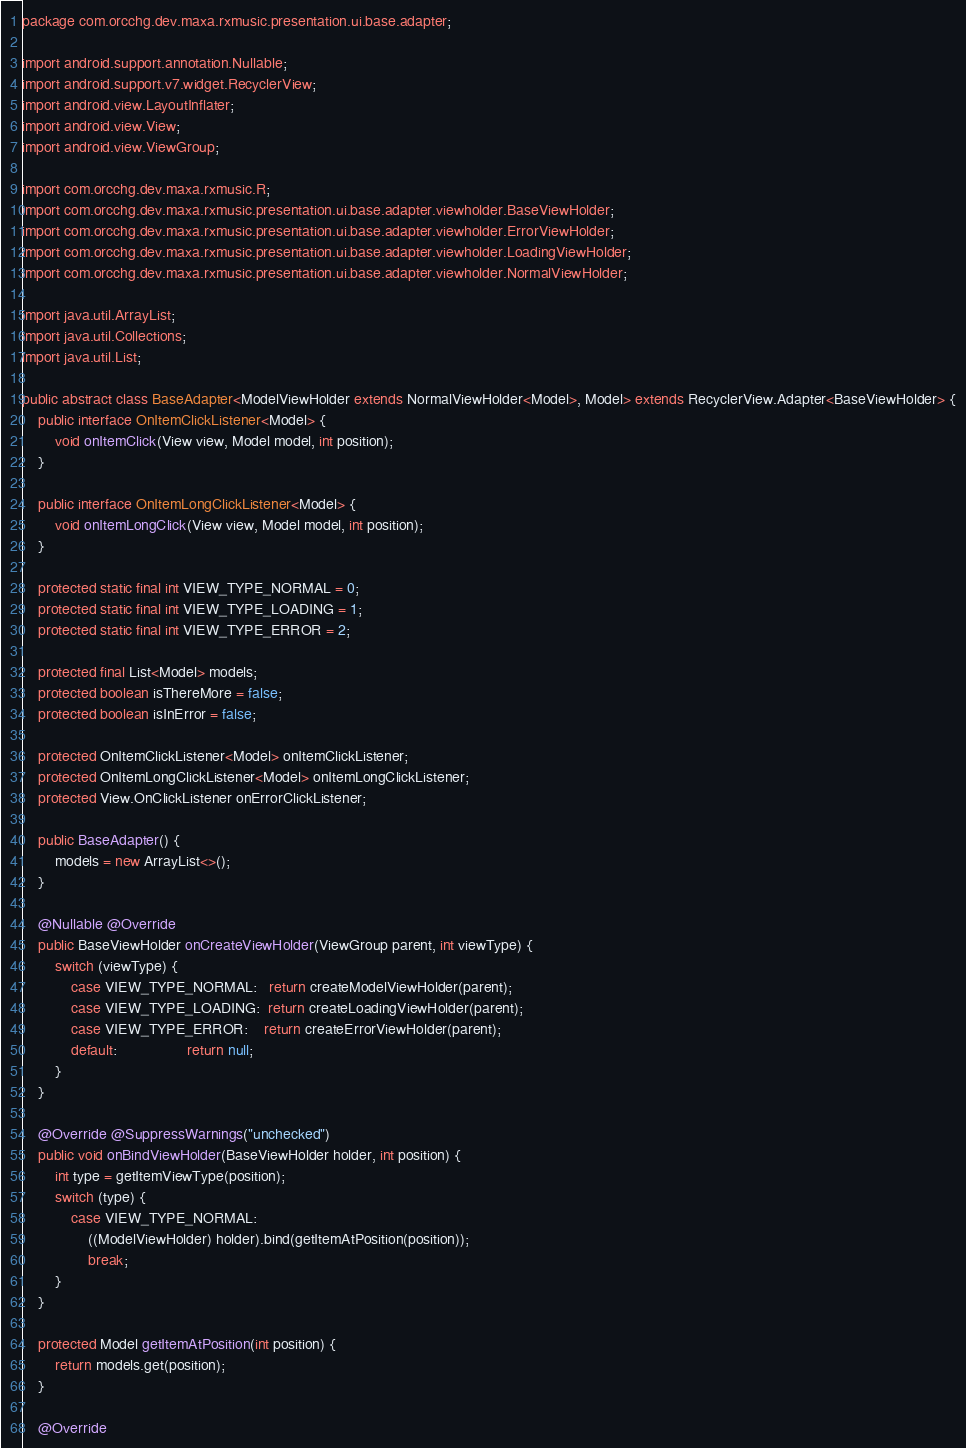<code> <loc_0><loc_0><loc_500><loc_500><_Java_>package com.orcchg.dev.maxa.rxmusic.presentation.ui.base.adapter;

import android.support.annotation.Nullable;
import android.support.v7.widget.RecyclerView;
import android.view.LayoutInflater;
import android.view.View;
import android.view.ViewGroup;

import com.orcchg.dev.maxa.rxmusic.R;
import com.orcchg.dev.maxa.rxmusic.presentation.ui.base.adapter.viewholder.BaseViewHolder;
import com.orcchg.dev.maxa.rxmusic.presentation.ui.base.adapter.viewholder.ErrorViewHolder;
import com.orcchg.dev.maxa.rxmusic.presentation.ui.base.adapter.viewholder.LoadingViewHolder;
import com.orcchg.dev.maxa.rxmusic.presentation.ui.base.adapter.viewholder.NormalViewHolder;

import java.util.ArrayList;
import java.util.Collections;
import java.util.List;

public abstract class BaseAdapter<ModelViewHolder extends NormalViewHolder<Model>, Model> extends RecyclerView.Adapter<BaseViewHolder> {
    public interface OnItemClickListener<Model> {
        void onItemClick(View view, Model model, int position);
    }

    public interface OnItemLongClickListener<Model> {
        void onItemLongClick(View view, Model model, int position);
    }

    protected static final int VIEW_TYPE_NORMAL = 0;
    protected static final int VIEW_TYPE_LOADING = 1;
    protected static final int VIEW_TYPE_ERROR = 2;

    protected final List<Model> models;
    protected boolean isThereMore = false;
    protected boolean isInError = false;

    protected OnItemClickListener<Model> onItemClickListener;
    protected OnItemLongClickListener<Model> onItemLongClickListener;
    protected View.OnClickListener onErrorClickListener;

    public BaseAdapter() {
        models = new ArrayList<>();
    }

    @Nullable @Override
    public BaseViewHolder onCreateViewHolder(ViewGroup parent, int viewType) {
        switch (viewType) {
            case VIEW_TYPE_NORMAL:   return createModelViewHolder(parent);
            case VIEW_TYPE_LOADING:  return createLoadingViewHolder(parent);
            case VIEW_TYPE_ERROR:    return createErrorViewHolder(parent);
            default:                 return null;
        }
    }

    @Override @SuppressWarnings("unchecked")
    public void onBindViewHolder(BaseViewHolder holder, int position) {
        int type = getItemViewType(position);
        switch (type) {
            case VIEW_TYPE_NORMAL:
                ((ModelViewHolder) holder).bind(getItemAtPosition(position));
                break;
        }
    }

    protected Model getItemAtPosition(int position) {
        return models.get(position);
    }

    @Override</code> 